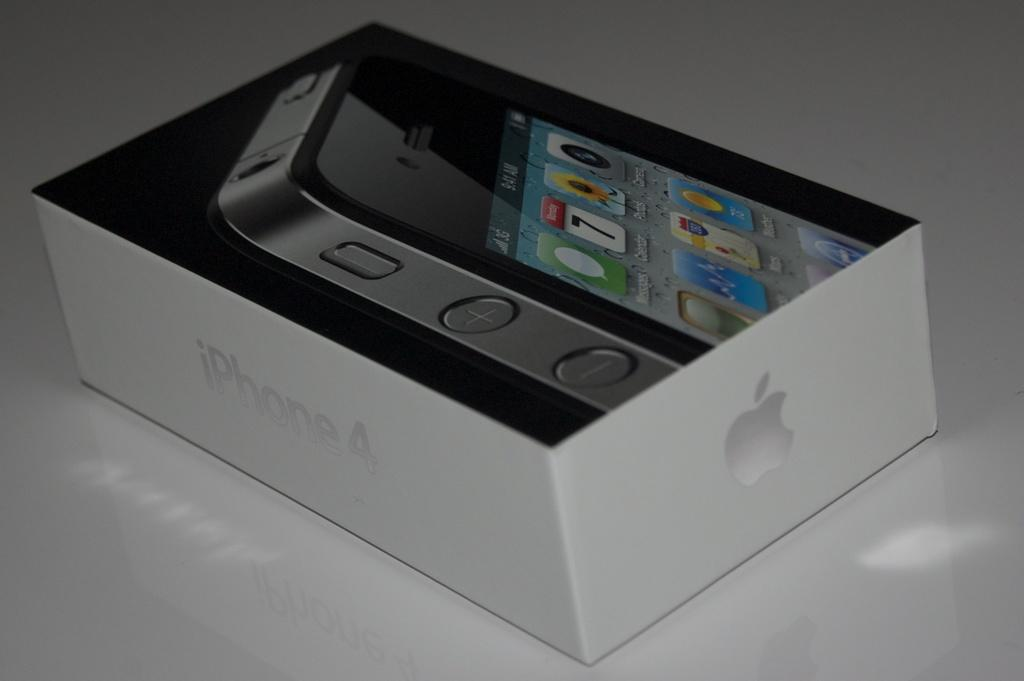<image>
Describe the image concisely. A white box of an iphone 4 cell phone. 